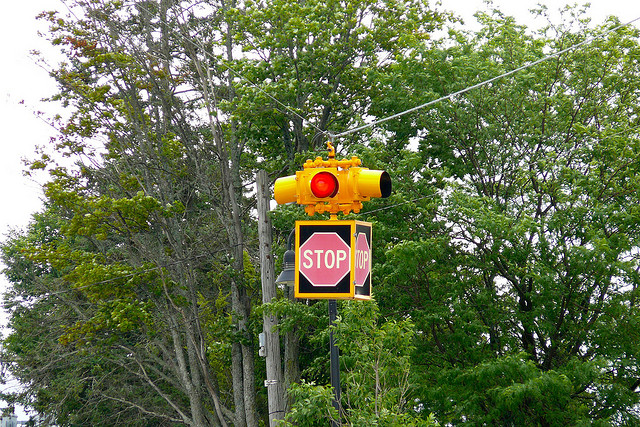Please transcribe the text in this image. STOP STOP 